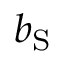Convert formula to latex. <formula><loc_0><loc_0><loc_500><loc_500>b _ { S }</formula> 